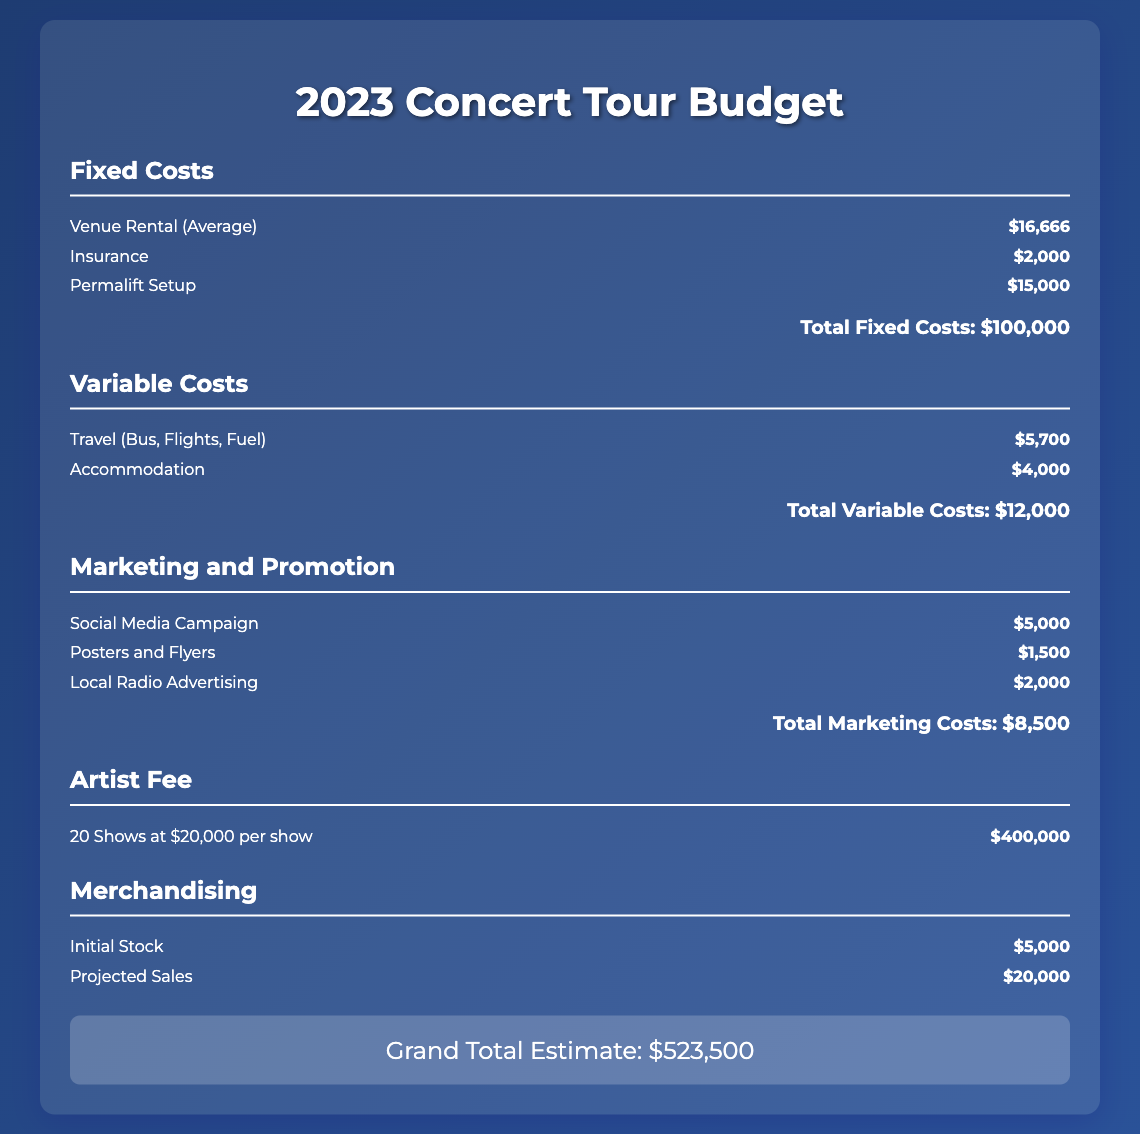What is the average venue rental cost? The average venue rental cost is mentioned in the budget under Fixed Costs, which is $16,666.
Answer: $16,666 What are the total fixed costs? The total fixed costs are calculated by summing up all fixed costs listed, which equals $100,000.
Answer: $100,000 How much is allocated for social media campaigns? The budget allocates $5,000 specifically for social media campaigns under Marketing and Promotion costs.
Answer: $5,000 What is the cost for 20 shows at $20,000 per show? The cost for 20 shows is determined by multiplying the number of shows by the per-show fee, resulting in $400,000.
Answer: $400,000 What is the total for marketing costs? The total for marketing costs is calculated by adding all the expenses related to marketing, which sums up to $8,500.
Answer: $8,500 What is the grand total estimate for the concert tour? The complete grand total estimate for the concert tour is presented at the end of the document as $523,500.
Answer: $523,500 How much is budgeted for travel expenses? The budget for travel expenses, including bus, flights, and fuel, is stated as $5,700 under Variable Costs.
Answer: $5,700 What is the projected sales for merchandising? The document lists projected sales for merchandising as $20,000.
Answer: $20,000 What is the insurance cost listed in the fixed costs? The fixed cost for insurance is explicitly stated as $2,000.
Answer: $2,000 